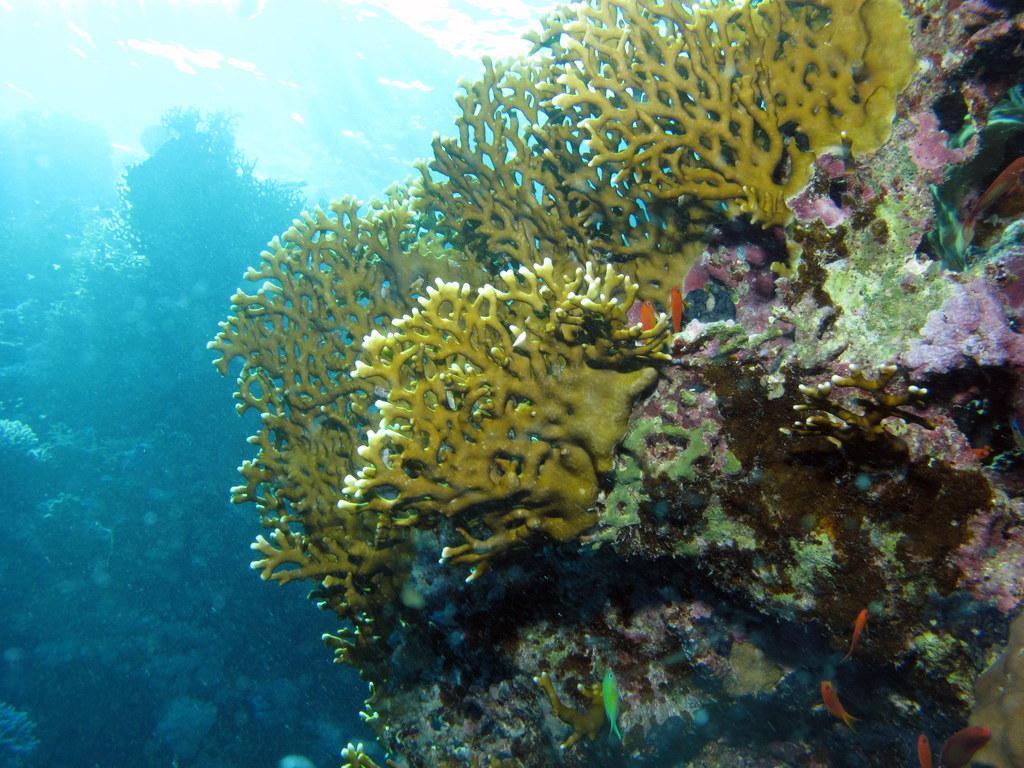Can you describe this image briefly? As we can see in the image there is water and plants. 